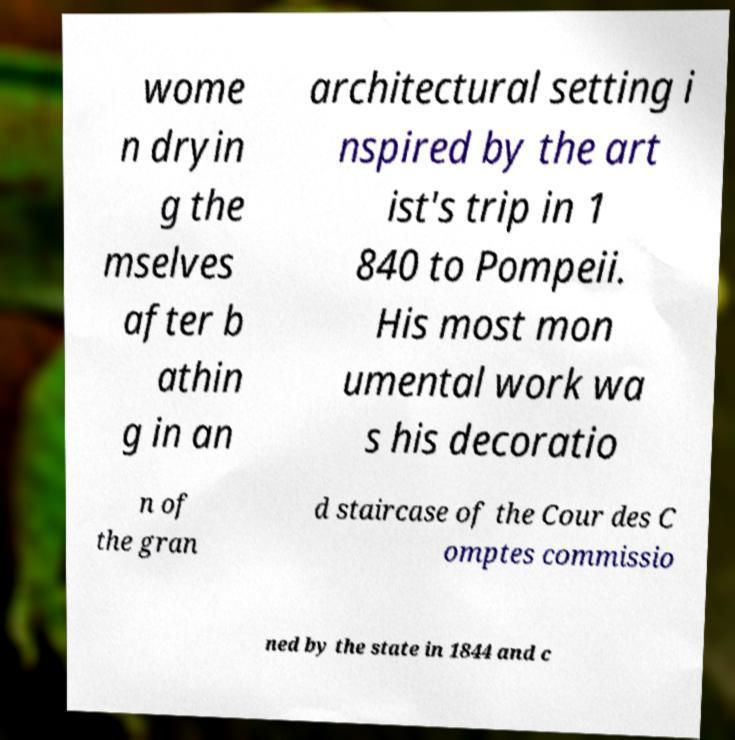There's text embedded in this image that I need extracted. Can you transcribe it verbatim? wome n dryin g the mselves after b athin g in an architectural setting i nspired by the art ist's trip in 1 840 to Pompeii. His most mon umental work wa s his decoratio n of the gran d staircase of the Cour des C omptes commissio ned by the state in 1844 and c 